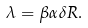Convert formula to latex. <formula><loc_0><loc_0><loc_500><loc_500>\lambda = \beta \alpha \delta R .</formula> 